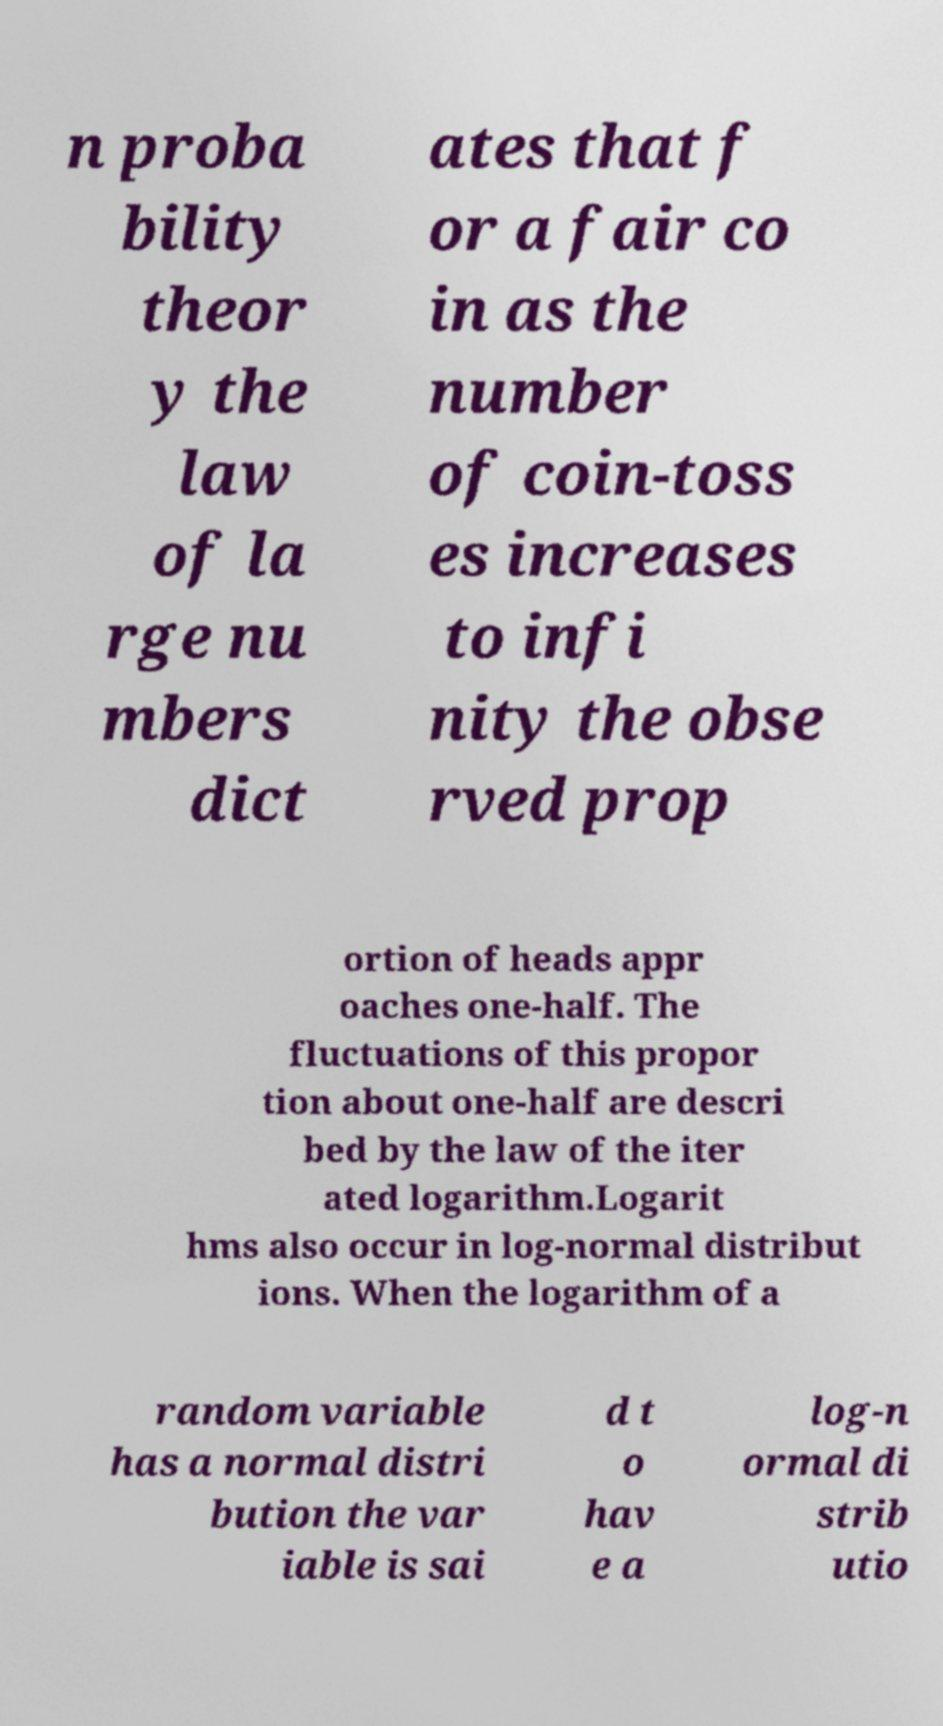Please read and relay the text visible in this image. What does it say? n proba bility theor y the law of la rge nu mbers dict ates that f or a fair co in as the number of coin-toss es increases to infi nity the obse rved prop ortion of heads appr oaches one-half. The fluctuations of this propor tion about one-half are descri bed by the law of the iter ated logarithm.Logarit hms also occur in log-normal distribut ions. When the logarithm of a random variable has a normal distri bution the var iable is sai d t o hav e a log-n ormal di strib utio 